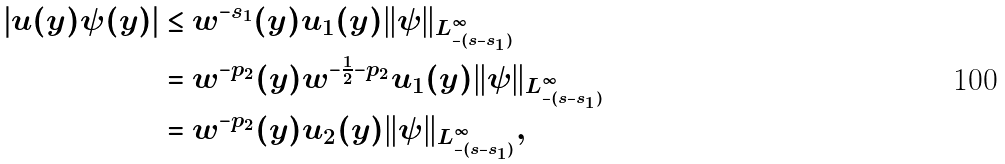Convert formula to latex. <formula><loc_0><loc_0><loc_500><loc_500>| u ( y ) \psi ( y ) | & \leq w ^ { - s _ { 1 } } ( y ) u _ { 1 } ( y ) \| \psi \| _ { L ^ { \infty } _ { - ( s - s _ { 1 } ) } } \\ & = w ^ { - p _ { 2 } } ( y ) w ^ { - \frac { 1 } { 2 } - p _ { 2 } } u _ { 1 } ( y ) \| \psi \| _ { L ^ { \infty } _ { - ( s - s _ { 1 } ) } } \\ & = w ^ { - p _ { 2 } } ( y ) u _ { 2 } ( y ) \| \psi \| _ { L ^ { \infty } _ { - ( s - s _ { 1 } ) } } ,</formula> 